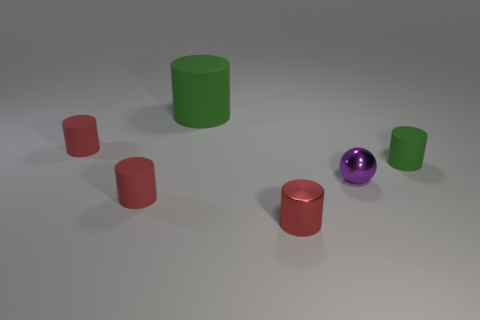Subtract all small rubber cylinders. How many cylinders are left? 2 Add 2 purple things. How many objects exist? 8 Subtract all green cylinders. How many cylinders are left? 3 Subtract all spheres. How many objects are left? 5 Subtract 1 spheres. How many spheres are left? 0 Subtract 0 red spheres. How many objects are left? 6 Subtract all green cylinders. Subtract all green balls. How many cylinders are left? 3 Subtract all gray spheres. How many red cylinders are left? 3 Subtract all purple metallic objects. Subtract all green cylinders. How many objects are left? 3 Add 4 matte cylinders. How many matte cylinders are left? 8 